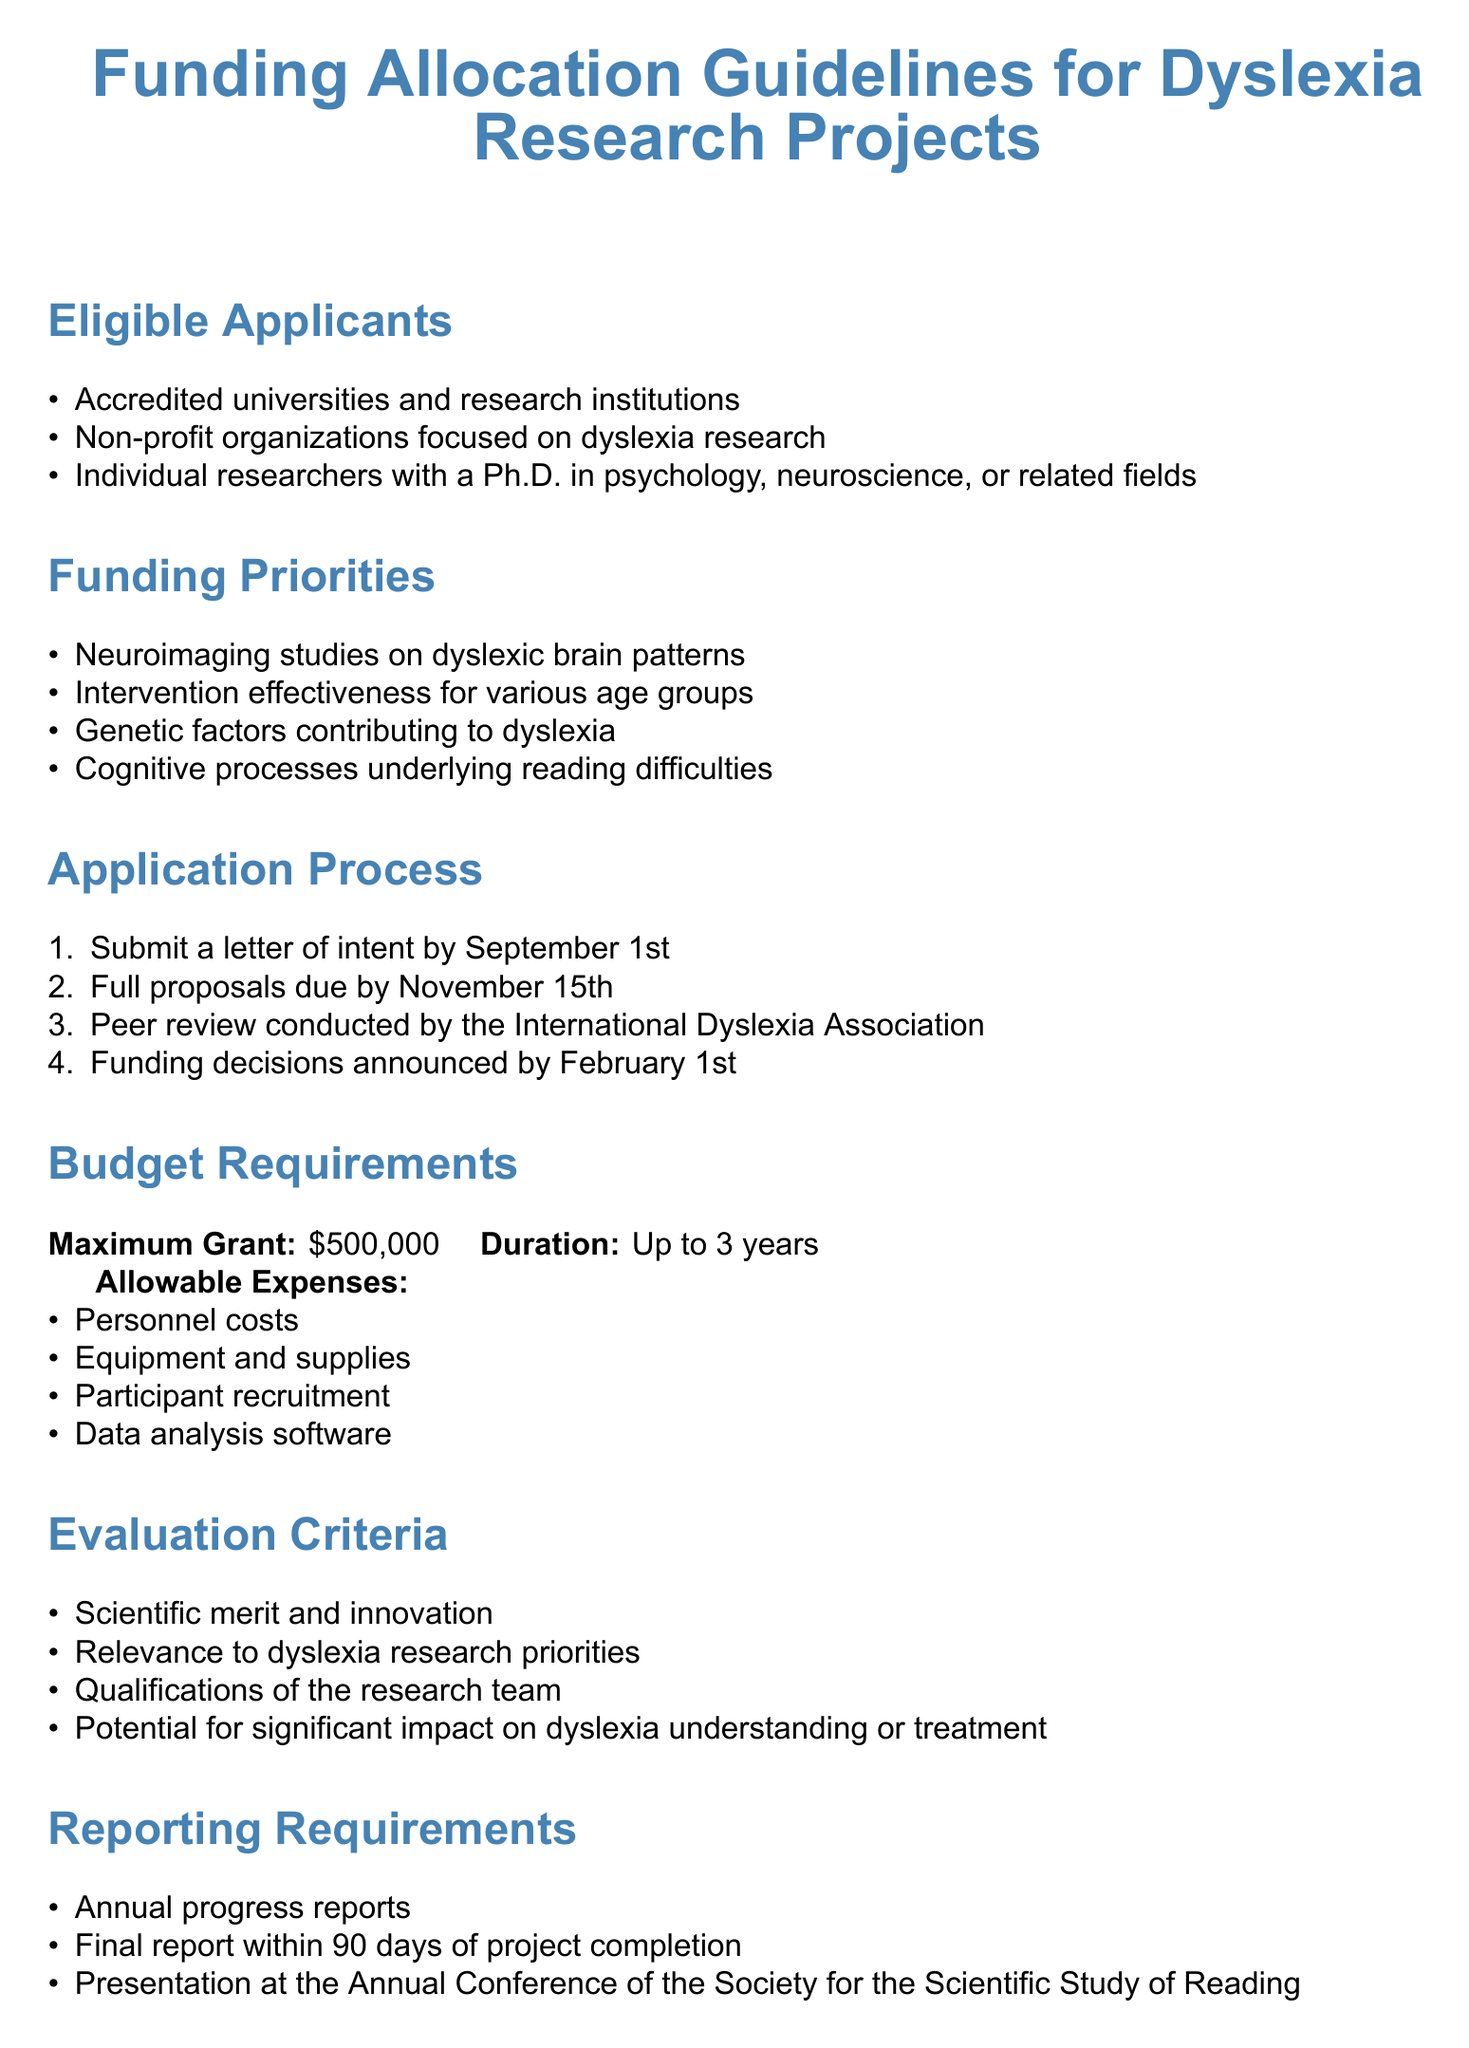What are the eligible applicants for funding? The document lists who can apply for funding under the eligible applicants section.
Answer: Accredited universities and research institutions, non-profit organizations focused on dyslexia research, individual researchers with a Ph.D. in psychology, neuroscience, or related fields What is the maximum grant amount? The document specifies the maximum grant available for applicants within the budget requirements section.
Answer: $500,000 What is the deadline for submitting a letter of intent? The application process outlines key dates, including when the letter of intent must be submitted.
Answer: September 1st Which organization conducts the peer review? The application process section indicates who is responsible for the peer review of proposals.
Answer: International Dyslexia Association List one allowable expense for the budget. The document states what expenses are permitted under the budget requirements section.
Answer: Personnel costs 